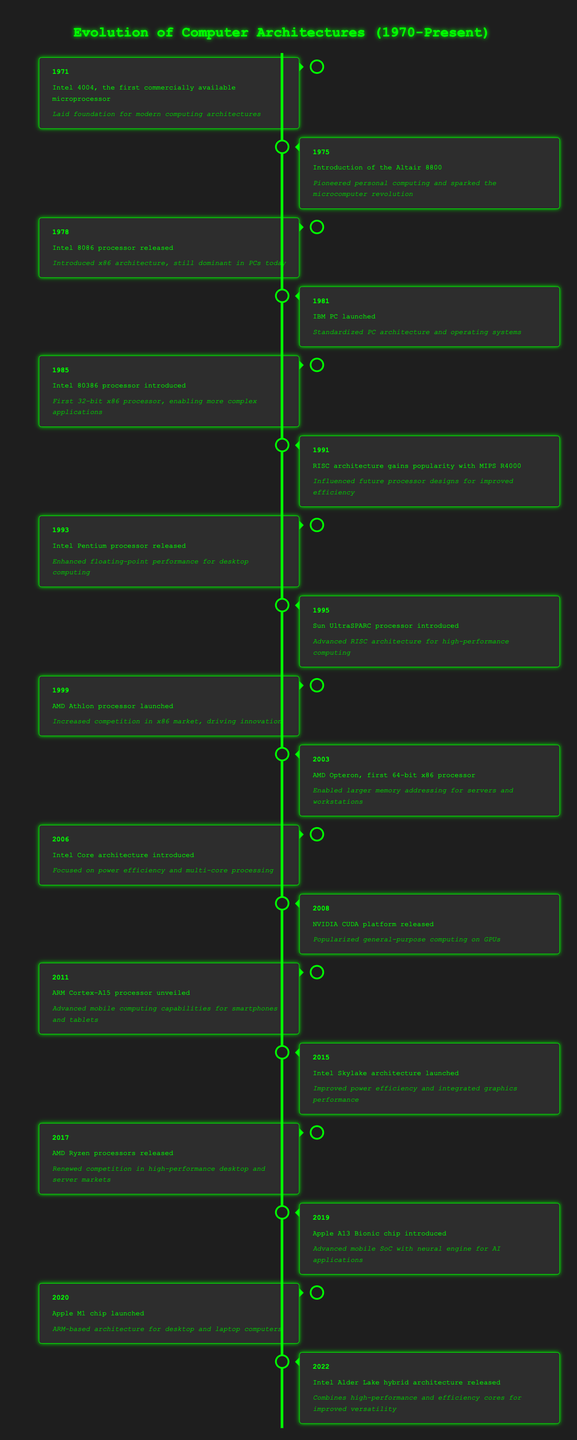What year was the Intel 4004 released? The table indicates that the Intel 4004 was released in 1971. This is found in the first entry of the timeline.
Answer: 1971 Which architecture was introduced by the Intel 8086 processor? According to the table, the Intel 8086 processor released in 1978 introduced the x86 architecture. This can be found in the entry for the year 1978.
Answer: x86 architecture How many years are between the launch of the IBM PC and the release of the AMD Opteron? The IBM PC was launched in 1981 and the AMD Opteron was released in 2003. The difference in years is 2003 - 1981 = 22 years.
Answer: 22 years Did the Intel Core architecture focus on power efficiency? The table describes that the Intel Core architecture introduced in 2006 focused on power efficiency and multi-core processing, confirming that it did.
Answer: Yes In which year was the ARM Cortex-A15 processor unveiled and what was its impact? The ARM Cortex-A15 processor was unveiled in 2011, and its impact was to advance mobile computing capabilities for smartphones and tablets, as noted in the timeline entry for 2011.
Answer: 2011; advanced mobile computing capabilities What was the impact of the Apple M1 chip launched in 2020? The table states that the Apple M1 chip, launched in 2020, features an ARM-based architecture for desktop and laptop computers, indicating its impact on the computing architecture landscape.
Answer: ARM-based architecture for desktop and laptop computers What is the period between the introduction of the Intel 80386 processor and the launch of the Apple A13 Bionic chip? The Intel 80386 processor was introduced in 1985 and the Apple A13 Bionic chip was introduced in 2019. Calculating the difference: 2019 - 1985 = 34 years.
Answer: 34 years Did the AMD Ryzen processors' release in 2017 renew competition in the desktop market? The timeline indicates in the 2017 entry that the AMD Ryzen processors released meant renewed competition in high-performance desktop and server markets, confirming the statement is true.
Answer: Yes What was unique about the Intel Alder Lake architecture released in 2022? The table highlights that the Intel Alder Lake architecture released in 2022 combined high-performance and efficiency cores for improved versatility, making it unique in its design approach.
Answer: Combined high-performance and efficiency cores 